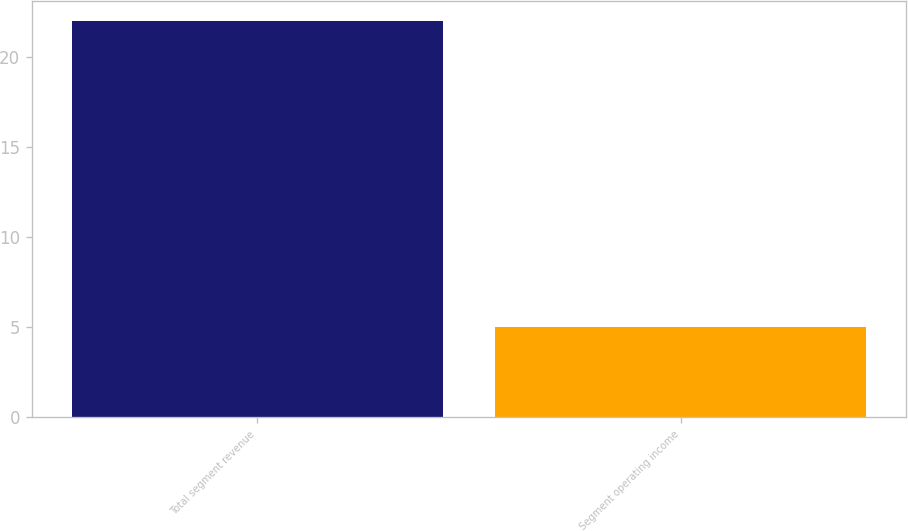<chart> <loc_0><loc_0><loc_500><loc_500><bar_chart><fcel>Total segment revenue<fcel>Segment operating income<nl><fcel>22<fcel>5<nl></chart> 